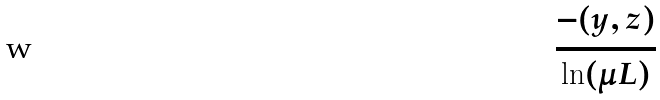<formula> <loc_0><loc_0><loc_500><loc_500>\frac { - ( y , z ) } { \ln ( \mu L ) }</formula> 